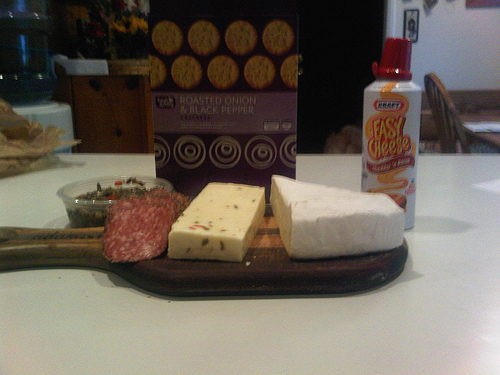<image>
Is the cheese in front of the crackers? Yes. The cheese is positioned in front of the crackers, appearing closer to the camera viewpoint. 